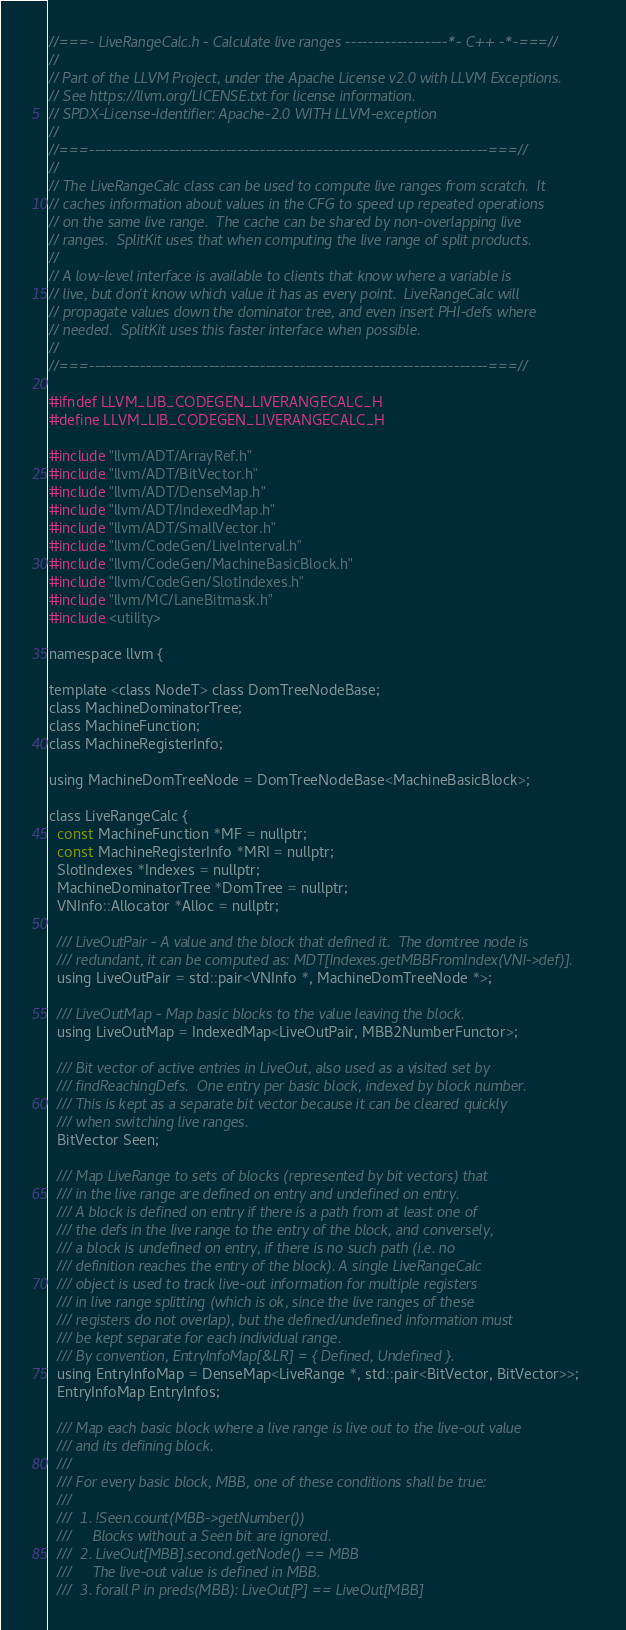<code> <loc_0><loc_0><loc_500><loc_500><_C_>//===- LiveRangeCalc.h - Calculate live ranges ------------------*- C++ -*-===//
//
// Part of the LLVM Project, under the Apache License v2.0 with LLVM Exceptions.
// See https://llvm.org/LICENSE.txt for license information.
// SPDX-License-Identifier: Apache-2.0 WITH LLVM-exception
//
//===----------------------------------------------------------------------===//
//
// The LiveRangeCalc class can be used to compute live ranges from scratch.  It
// caches information about values in the CFG to speed up repeated operations
// on the same live range.  The cache can be shared by non-overlapping live
// ranges.  SplitKit uses that when computing the live range of split products.
//
// A low-level interface is available to clients that know where a variable is
// live, but don't know which value it has as every point.  LiveRangeCalc will
// propagate values down the dominator tree, and even insert PHI-defs where
// needed.  SplitKit uses this faster interface when possible.
//
//===----------------------------------------------------------------------===//

#ifndef LLVM_LIB_CODEGEN_LIVERANGECALC_H
#define LLVM_LIB_CODEGEN_LIVERANGECALC_H

#include "llvm/ADT/ArrayRef.h"
#include "llvm/ADT/BitVector.h"
#include "llvm/ADT/DenseMap.h"
#include "llvm/ADT/IndexedMap.h"
#include "llvm/ADT/SmallVector.h"
#include "llvm/CodeGen/LiveInterval.h"
#include "llvm/CodeGen/MachineBasicBlock.h"
#include "llvm/CodeGen/SlotIndexes.h"
#include "llvm/MC/LaneBitmask.h"
#include <utility>

namespace llvm {

template <class NodeT> class DomTreeNodeBase;
class MachineDominatorTree;
class MachineFunction;
class MachineRegisterInfo;

using MachineDomTreeNode = DomTreeNodeBase<MachineBasicBlock>;

class LiveRangeCalc {
  const MachineFunction *MF = nullptr;
  const MachineRegisterInfo *MRI = nullptr;
  SlotIndexes *Indexes = nullptr;
  MachineDominatorTree *DomTree = nullptr;
  VNInfo::Allocator *Alloc = nullptr;

  /// LiveOutPair - A value and the block that defined it.  The domtree node is
  /// redundant, it can be computed as: MDT[Indexes.getMBBFromIndex(VNI->def)].
  using LiveOutPair = std::pair<VNInfo *, MachineDomTreeNode *>;

  /// LiveOutMap - Map basic blocks to the value leaving the block.
  using LiveOutMap = IndexedMap<LiveOutPair, MBB2NumberFunctor>;

  /// Bit vector of active entries in LiveOut, also used as a visited set by
  /// findReachingDefs.  One entry per basic block, indexed by block number.
  /// This is kept as a separate bit vector because it can be cleared quickly
  /// when switching live ranges.
  BitVector Seen;

  /// Map LiveRange to sets of blocks (represented by bit vectors) that
  /// in the live range are defined on entry and undefined on entry.
  /// A block is defined on entry if there is a path from at least one of
  /// the defs in the live range to the entry of the block, and conversely,
  /// a block is undefined on entry, if there is no such path (i.e. no
  /// definition reaches the entry of the block). A single LiveRangeCalc
  /// object is used to track live-out information for multiple registers
  /// in live range splitting (which is ok, since the live ranges of these
  /// registers do not overlap), but the defined/undefined information must
  /// be kept separate for each individual range.
  /// By convention, EntryInfoMap[&LR] = { Defined, Undefined }.
  using EntryInfoMap = DenseMap<LiveRange *, std::pair<BitVector, BitVector>>;
  EntryInfoMap EntryInfos;

  /// Map each basic block where a live range is live out to the live-out value
  /// and its defining block.
  ///
  /// For every basic block, MBB, one of these conditions shall be true:
  ///
  ///  1. !Seen.count(MBB->getNumber())
  ///     Blocks without a Seen bit are ignored.
  ///  2. LiveOut[MBB].second.getNode() == MBB
  ///     The live-out value is defined in MBB.
  ///  3. forall P in preds(MBB): LiveOut[P] == LiveOut[MBB]</code> 